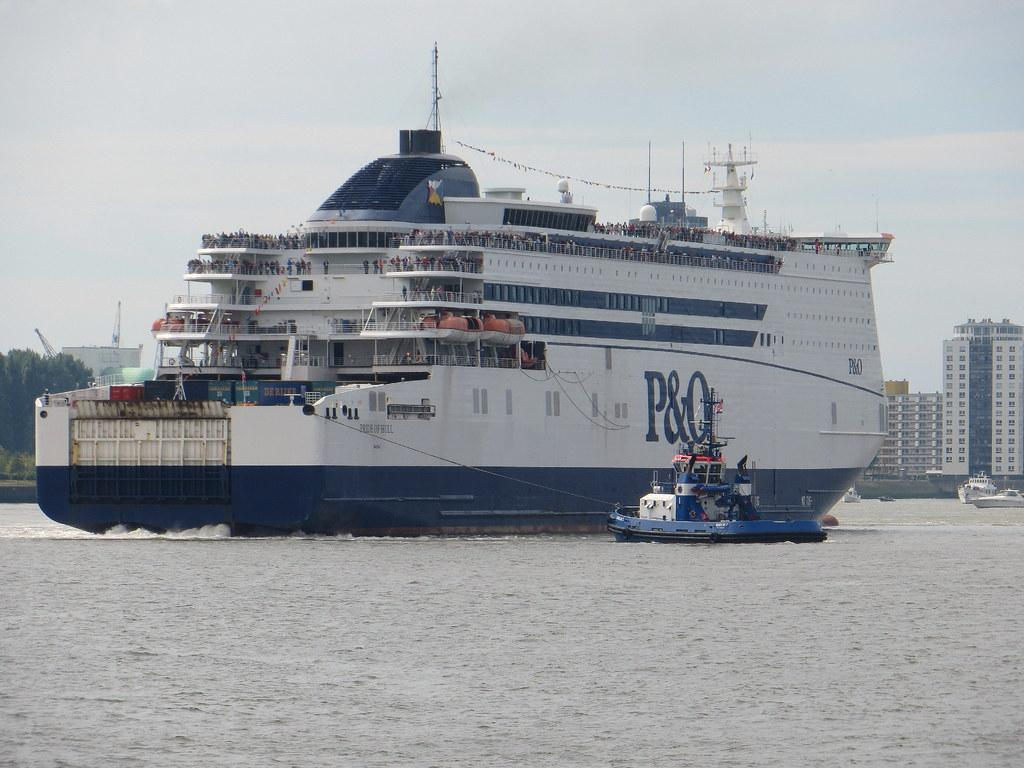Provide a one-sentence caption for the provided image. a boat with the large letter P on it. 